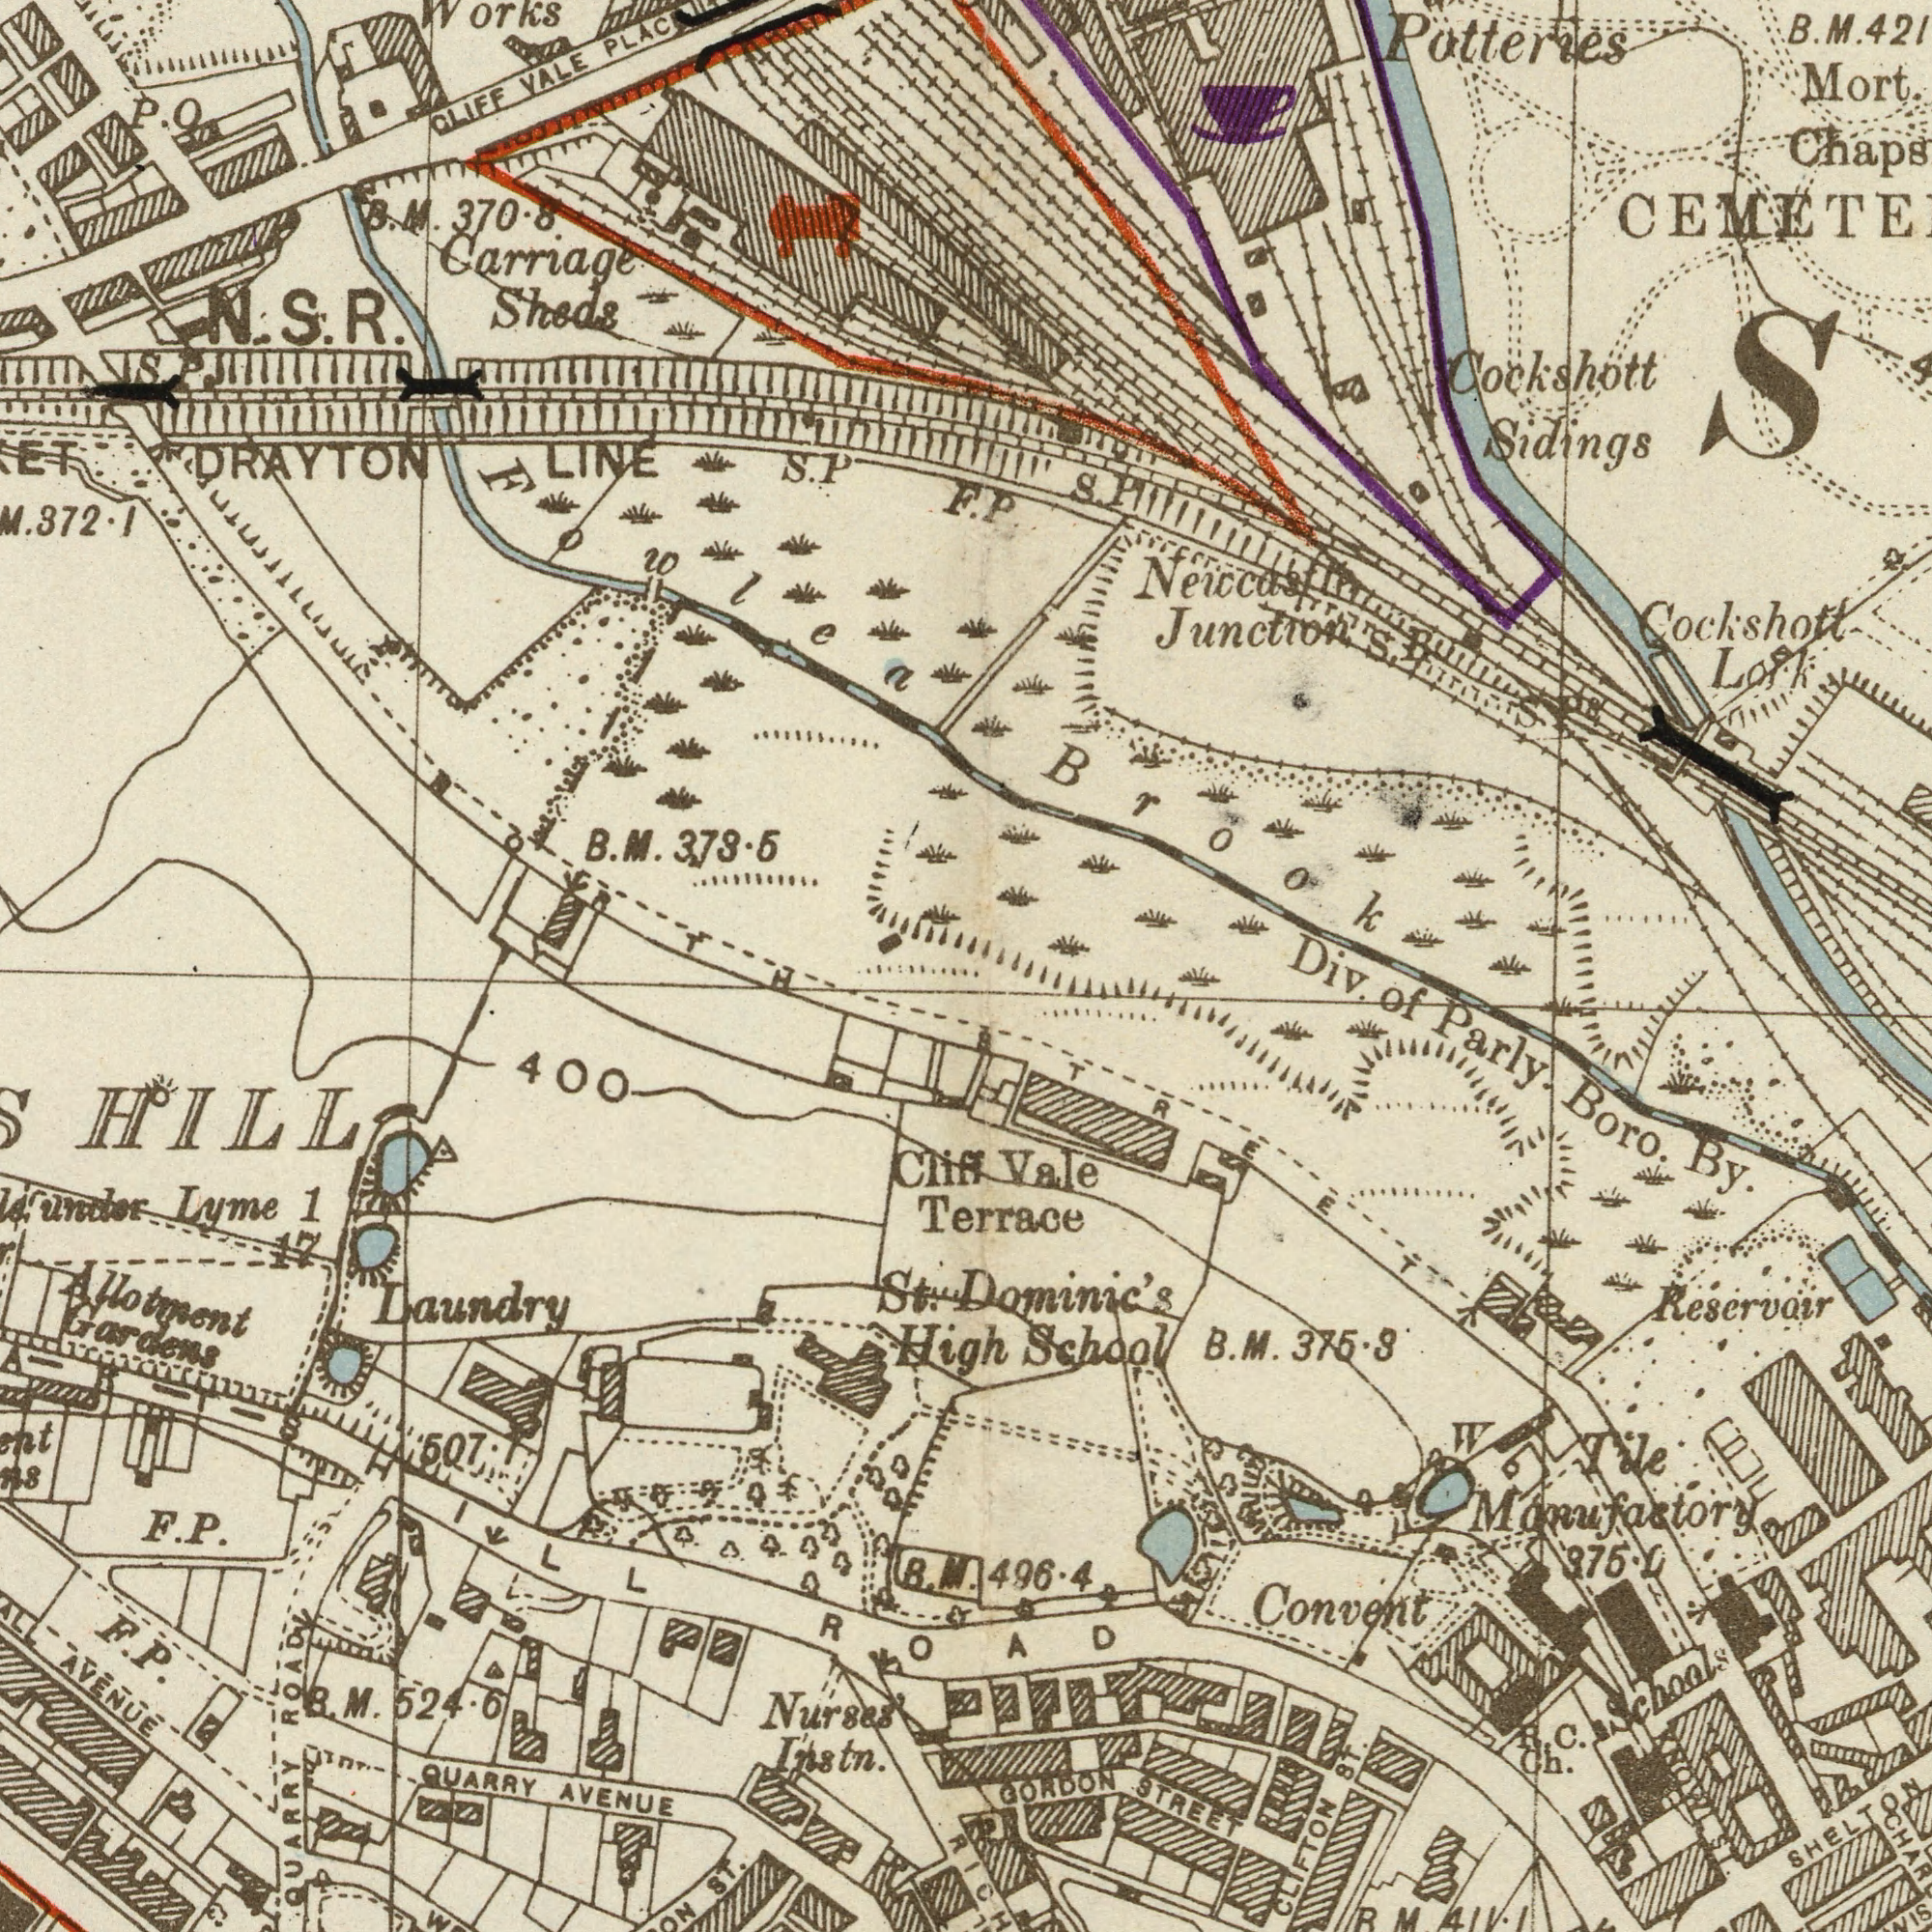What text is shown in the top-right quadrant? Mort. Junction Sidings Cockshott Cockshott Potteries Neiccast P S. B. Brook Div. M. S. P R S. P What text is shown in the bottom-right quadrant? Convent STREET GORDON Boro. Parly. CLIFTON Vale B. 375.3 Ch. Dominic's W School Reservoir 496.4 ###75.### Manufactory Terrace of Schools C. St. Tile By. SHELTON M. STREET ROAD 411.1 R M R. ST. What text can you see in the bottom-left section? QUARRY Nurses 1 AVENUE 400 Lyme QUARRY F. Allotment ST. F. Instn. AVENUE High Laundry 507 M. Gardens B. HILL ROAD Cliff 524.6 St. under R. P. M. P. HILL 17 What text appears in the top-left area of the image? Carriage S. DRAYTON CLIFF B. VALE Sheds 373.5 M. 370.8 LINE Works B. N. P. O M. S. R. 372.1 Fowlea P F. S. P M. NORTH 